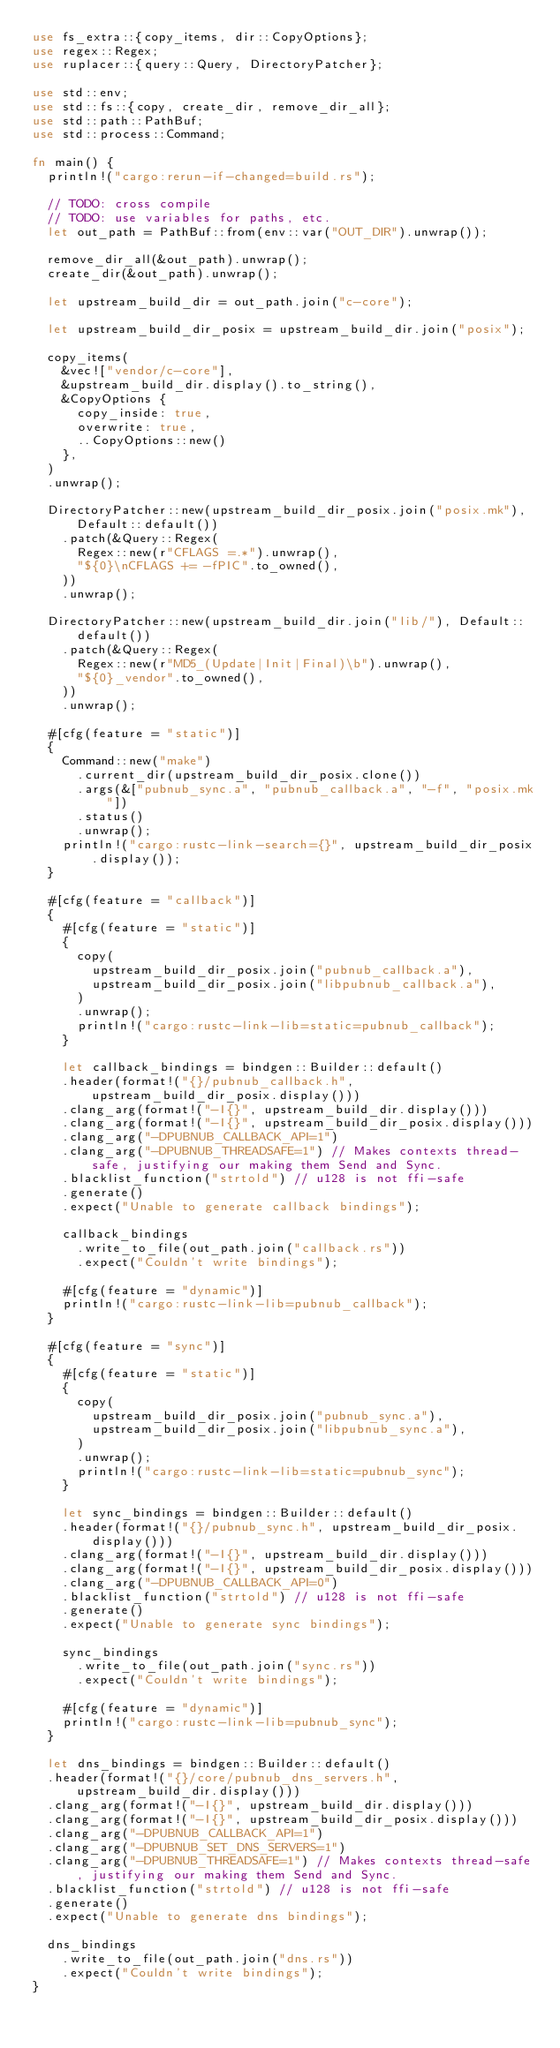Convert code to text. <code><loc_0><loc_0><loc_500><loc_500><_Rust_>use fs_extra::{copy_items, dir::CopyOptions};
use regex::Regex;
use ruplacer::{query::Query, DirectoryPatcher};

use std::env;
use std::fs::{copy, create_dir, remove_dir_all};
use std::path::PathBuf;
use std::process::Command;

fn main() {
  println!("cargo:rerun-if-changed=build.rs");

  // TODO: cross compile
  // TODO: use variables for paths, etc.
  let out_path = PathBuf::from(env::var("OUT_DIR").unwrap());

  remove_dir_all(&out_path).unwrap();
  create_dir(&out_path).unwrap();

  let upstream_build_dir = out_path.join("c-core");

  let upstream_build_dir_posix = upstream_build_dir.join("posix");

  copy_items(
    &vec!["vendor/c-core"],
    &upstream_build_dir.display().to_string(),
    &CopyOptions {
      copy_inside: true,
      overwrite: true,
      ..CopyOptions::new()
    },
  )
  .unwrap();

  DirectoryPatcher::new(upstream_build_dir_posix.join("posix.mk"), Default::default())
    .patch(&Query::Regex(
      Regex::new(r"CFLAGS =.*").unwrap(),
      "${0}\nCFLAGS += -fPIC".to_owned(),
    ))
    .unwrap();

  DirectoryPatcher::new(upstream_build_dir.join("lib/"), Default::default())
    .patch(&Query::Regex(
      Regex::new(r"MD5_(Update|Init|Final)\b").unwrap(),
      "${0}_vendor".to_owned(),
    ))
    .unwrap();

  #[cfg(feature = "static")]
  {
    Command::new("make")
      .current_dir(upstream_build_dir_posix.clone())
      .args(&["pubnub_sync.a", "pubnub_callback.a", "-f", "posix.mk"])
      .status()
      .unwrap();
    println!("cargo:rustc-link-search={}", upstream_build_dir_posix.display());
  }

  #[cfg(feature = "callback")]
  {
    #[cfg(feature = "static")]
    {
      copy(
        upstream_build_dir_posix.join("pubnub_callback.a"),
        upstream_build_dir_posix.join("libpubnub_callback.a"),
      )
      .unwrap();
      println!("cargo:rustc-link-lib=static=pubnub_callback");
    }

    let callback_bindings = bindgen::Builder::default()
    .header(format!("{}/pubnub_callback.h", upstream_build_dir_posix.display()))
    .clang_arg(format!("-I{}", upstream_build_dir.display()))
    .clang_arg(format!("-I{}", upstream_build_dir_posix.display()))
    .clang_arg("-DPUBNUB_CALLBACK_API=1")
    .clang_arg("-DPUBNUB_THREADSAFE=1") // Makes contexts thread-safe, justifying our making them Send and Sync.
    .blacklist_function("strtold") // u128 is not ffi-safe
    .generate()
    .expect("Unable to generate callback bindings");

    callback_bindings
      .write_to_file(out_path.join("callback.rs"))
      .expect("Couldn't write bindings");

    #[cfg(feature = "dynamic")]
    println!("cargo:rustc-link-lib=pubnub_callback");
  }

  #[cfg(feature = "sync")]
  {
    #[cfg(feature = "static")]
    {
      copy(
        upstream_build_dir_posix.join("pubnub_sync.a"),
        upstream_build_dir_posix.join("libpubnub_sync.a"),
      )
      .unwrap();
      println!("cargo:rustc-link-lib=static=pubnub_sync");
    }

    let sync_bindings = bindgen::Builder::default()
    .header(format!("{}/pubnub_sync.h", upstream_build_dir_posix.display()))
    .clang_arg(format!("-I{}", upstream_build_dir.display()))
    .clang_arg(format!("-I{}", upstream_build_dir_posix.display()))
    .clang_arg("-DPUBNUB_CALLBACK_API=0")
    .blacklist_function("strtold") // u128 is not ffi-safe
    .generate()
    .expect("Unable to generate sync bindings");

    sync_bindings
      .write_to_file(out_path.join("sync.rs"))
      .expect("Couldn't write bindings");

    #[cfg(feature = "dynamic")]
    println!("cargo:rustc-link-lib=pubnub_sync");
  }

  let dns_bindings = bindgen::Builder::default()
  .header(format!("{}/core/pubnub_dns_servers.h", upstream_build_dir.display()))
  .clang_arg(format!("-I{}", upstream_build_dir.display()))
  .clang_arg(format!("-I{}", upstream_build_dir_posix.display()))
  .clang_arg("-DPUBNUB_CALLBACK_API=1")
  .clang_arg("-DPUBNUB_SET_DNS_SERVERS=1")
  .clang_arg("-DPUBNUB_THREADSAFE=1") // Makes contexts thread-safe, justifying our making them Send and Sync.
  .blacklist_function("strtold") // u128 is not ffi-safe
  .generate()
  .expect("Unable to generate dns bindings");

  dns_bindings
    .write_to_file(out_path.join("dns.rs"))
    .expect("Couldn't write bindings");
}
</code> 